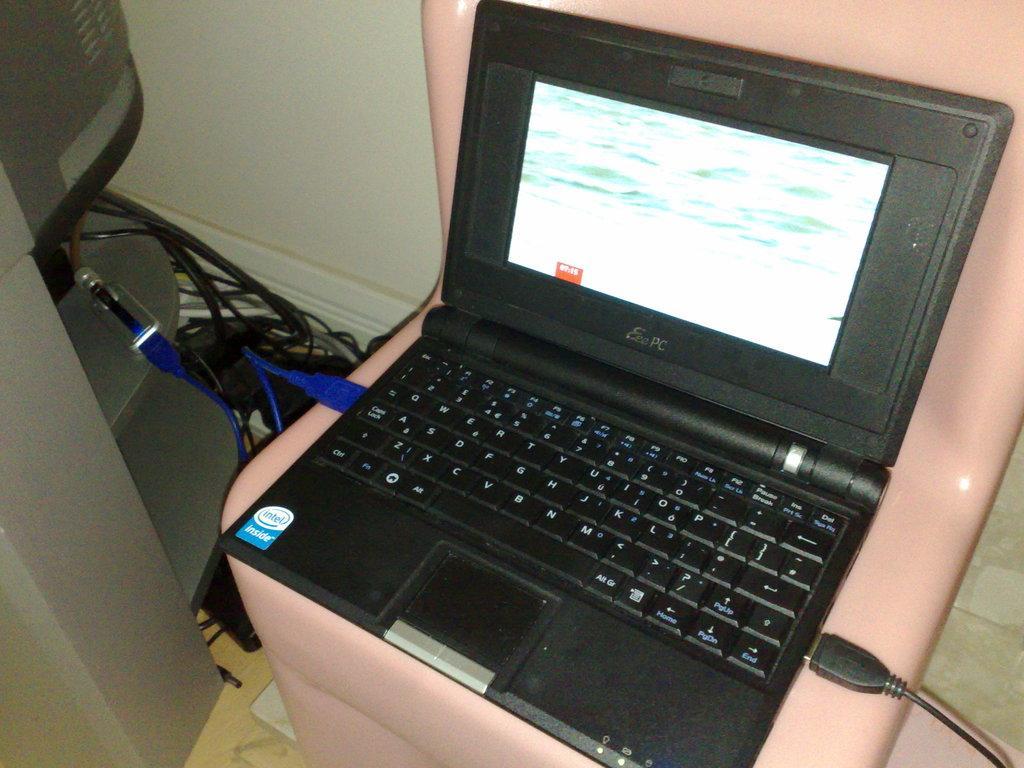How would you summarize this image in a sentence or two? In this picture I can see the laptop. I can see the wires on the left side. 